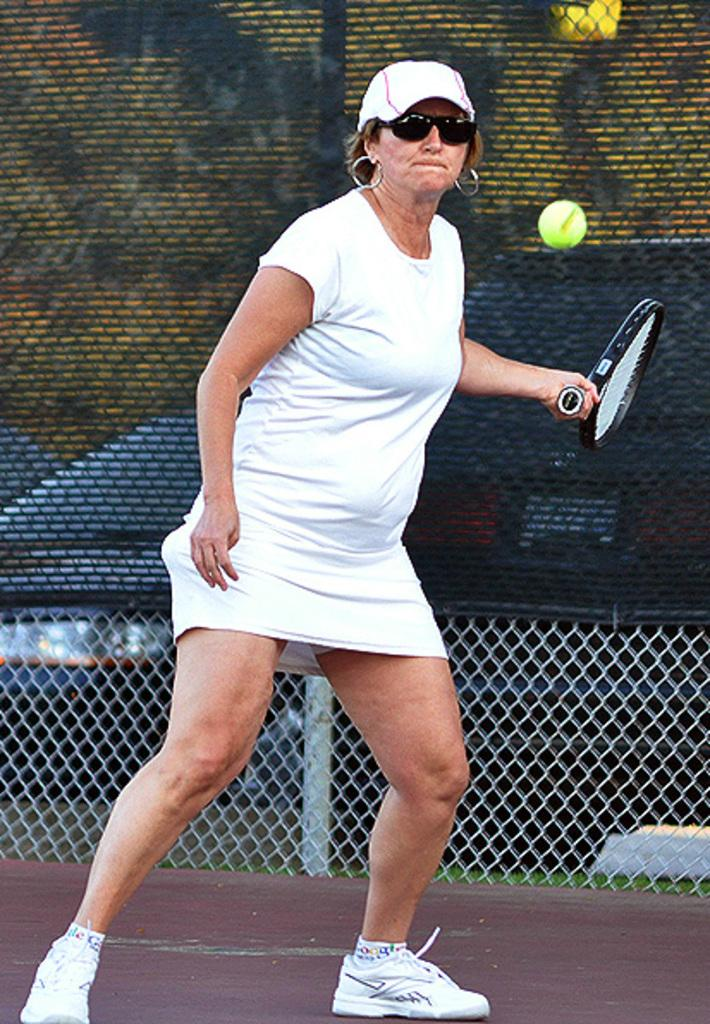Who is the main subject in the image? There is a woman in the image. What is the woman doing in the image? The woman is playing tennis. What object is the woman holding in the image? The woman is holding a tennis bat. What can be seen in the background of the image? There is fencing behind the woman. How much profit did the woman make from playing tennis in the image? There is no information about profit in the image, as it focuses on the woman playing tennis and holding a tennis bat. 